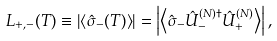Convert formula to latex. <formula><loc_0><loc_0><loc_500><loc_500>L _ { + , - } ( T ) \equiv \left | \left \langle \hat { \sigma } _ { - } ( T ) \right \rangle \right | = \left | \left \langle \hat { \sigma } _ { - } \hat { U } ^ { ( N ) \dag } _ { - } \hat { U } ^ { ( N ) } _ { + } \right \rangle \right | ,</formula> 